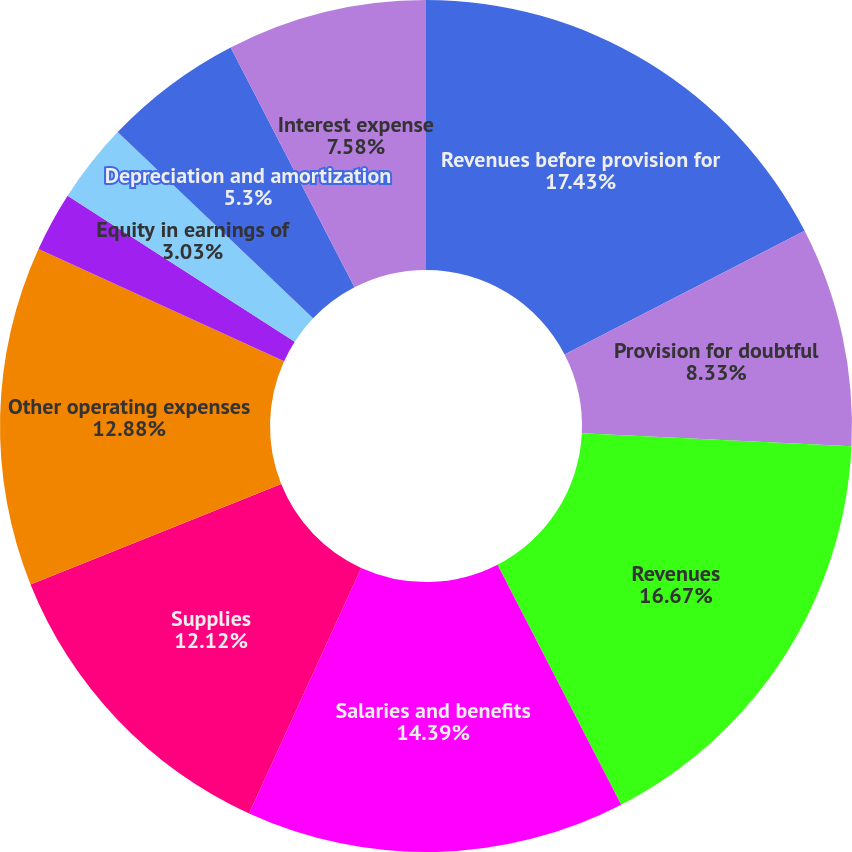Convert chart to OTSL. <chart><loc_0><loc_0><loc_500><loc_500><pie_chart><fcel>Revenues before provision for<fcel>Provision for doubtful<fcel>Revenues<fcel>Salaries and benefits<fcel>Supplies<fcel>Other operating expenses<fcel>Electronic health record<fcel>Equity in earnings of<fcel>Depreciation and amortization<fcel>Interest expense<nl><fcel>17.42%<fcel>8.33%<fcel>16.67%<fcel>14.39%<fcel>12.12%<fcel>12.88%<fcel>2.27%<fcel>3.03%<fcel>5.3%<fcel>7.58%<nl></chart> 